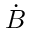Convert formula to latex. <formula><loc_0><loc_0><loc_500><loc_500>\dot { B }</formula> 